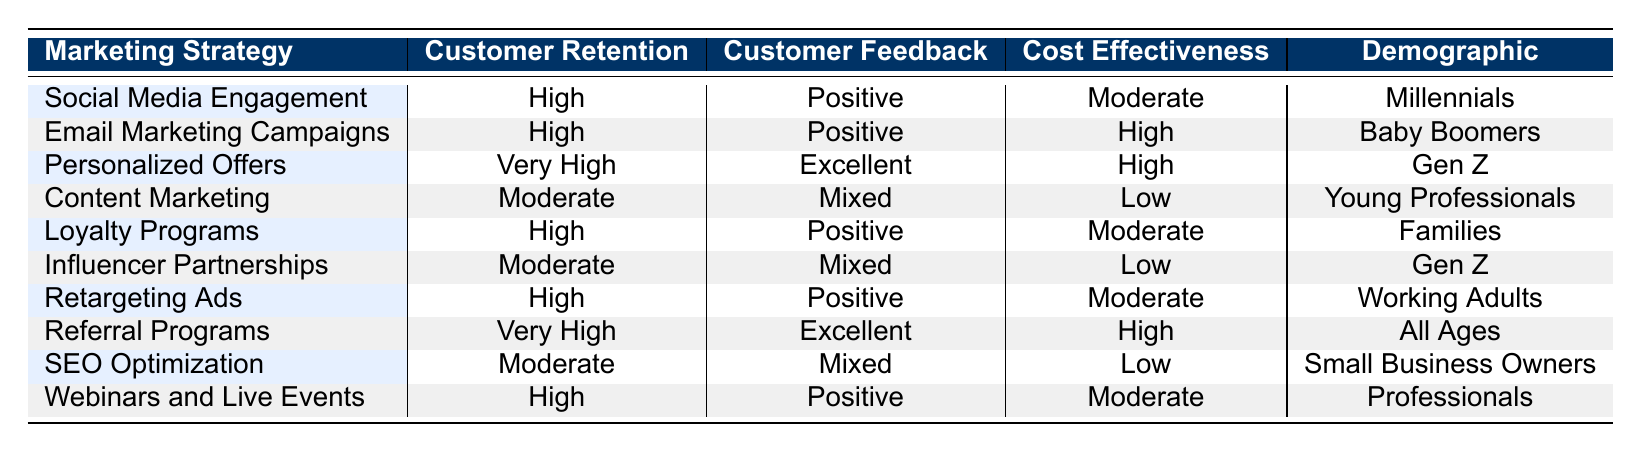What marketing strategy has the highest customer retention rate? The table shows two strategies with the highest retention rate labeled as "Very High": Personalized Offers and Referral Programs.
Answer: Personalized Offers and Referral Programs What cost-effectiveness rating is associated with "Content Marketing"? The Cost Effectiveness column indicates that Content Marketing has a rating of "Low".
Answer: Low Is customer feedback for Loyalty Programs positive? According to the table, the customer feedback for Loyalty Programs is listed as "Positive".
Answer: Yes Which demographic has a "Moderate" customer retention rate? By reviewing each row, only Content Marketing and Influencer Partnerships display a "Moderate" customer retention rate.
Answer: Young Professionals and Gen Z How does the cost effectiveness of "Personalized Offers" compare to "Email Marketing Campaigns"? The Cost Effectiveness for Personalized Offers is "High" while for Email Marketing Campaigns it is also "High", meaning they are equal.
Answer: They are equal Is there any marketing strategy that targets "All Ages"? The table shows that Referral Programs target "All Ages".
Answer: Yes What is the relationship between high customer retention and customer feedback in this table? High customer retention appears consistently associated with Positive or Excellent customer feedback, as seen in the strategies of Social Media Engagement, Email Marketing Campaigns, Loyalty Programs, Retargeting Ads, and Referral Programs.
Answer: Positive or Excellent feedback Which strategy has mixed customer feedback and low cost effectiveness? By examining the table, the strategies with Mixed customer feedback and Low cost effectiveness are Content Marketing and Influencer Partnerships.
Answer: Content Marketing and Influencer Partnerships What is the average customer retention rate for the various marketing strategies? To find the average, we classify customer retention as follows: Very High (2), High (5), Moderate (3). Calculating an average requires assigning numerical values: Very High (4), High (3), Moderate (2), resulting in (4*2 + 3*5 + 2*3) / 10 = 3.
Answer: Average retention rate of 3 (High) 